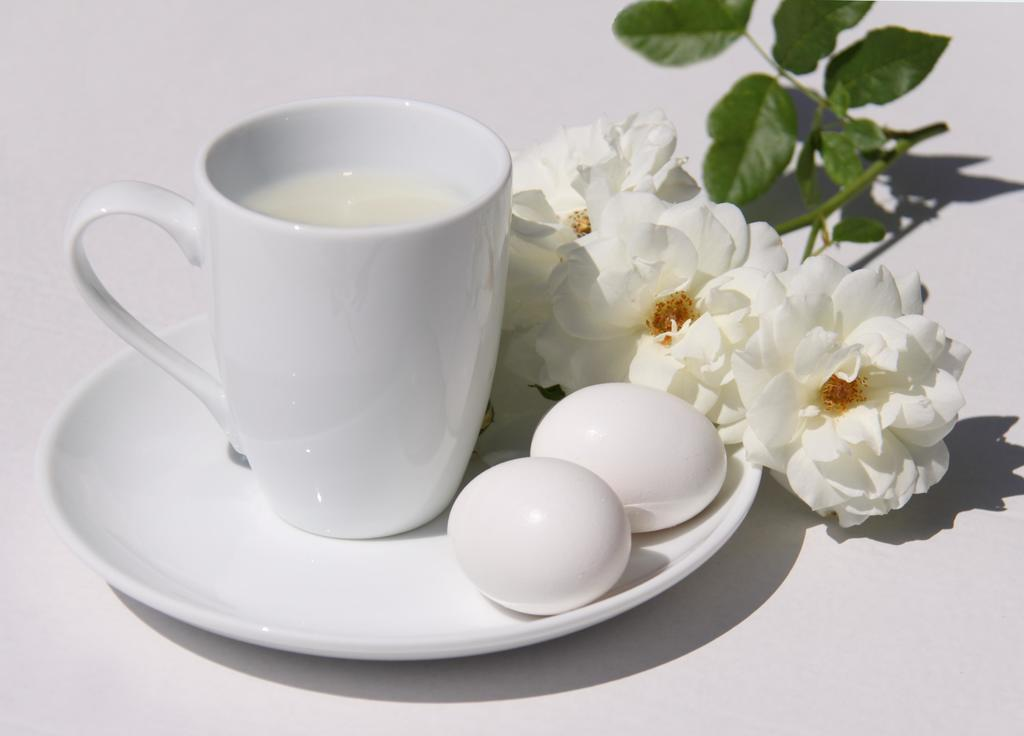What is placed on the plate in the image? There are two eggs, a group of flowers, and a group of leaves on stems placed on the plate. What is contained in the cup in the image? The cup contains a drink. How is the cup positioned in relation to the plate? The cup is placed on a plate. What type of food is present on the plate? There are two eggs on the plate. What type of decoration is present on the plate? There is a group of flowers and a group of leaves on stems on the plate. What is the value of the advertisement on the plate? There is no advertisement present on the plate; it features two eggs, a group of flowers, and a group of leaves on stems. What type of neck is visible on the plate? There is no neck visible on the plate; it features two eggs, a group of flowers, and a group of leaves on stems. 